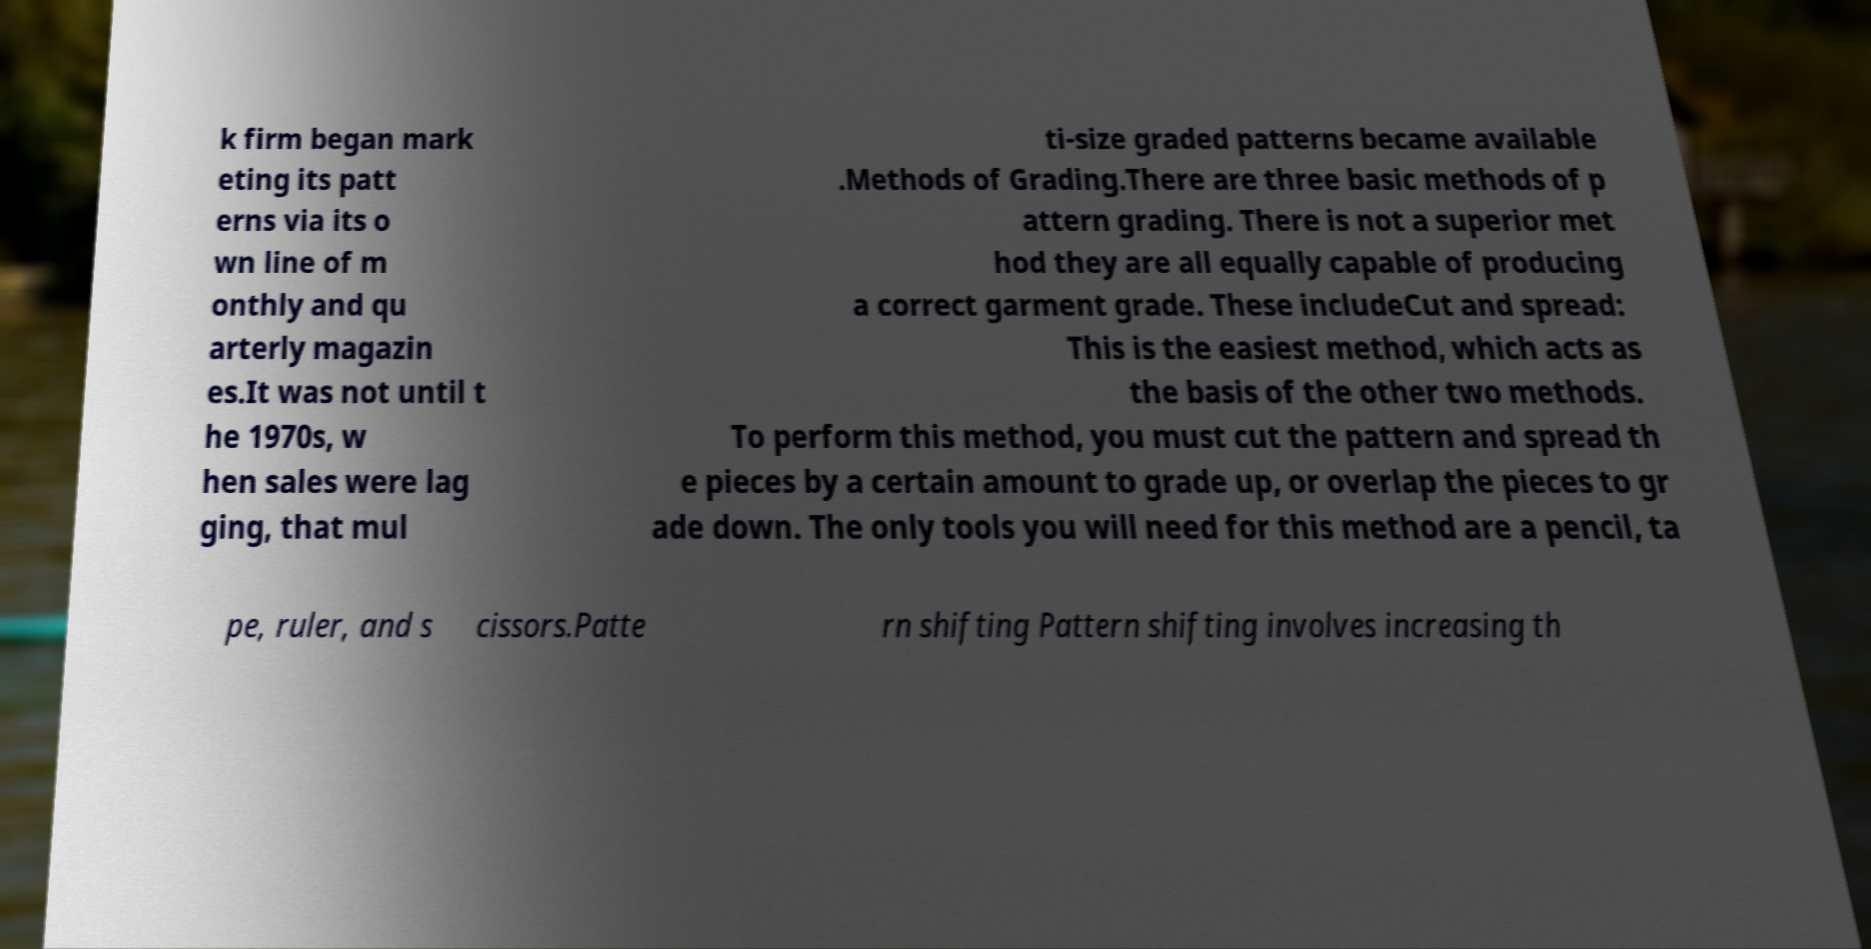Please read and relay the text visible in this image. What does it say? k firm began mark eting its patt erns via its o wn line of m onthly and qu arterly magazin es.It was not until t he 1970s, w hen sales were lag ging, that mul ti-size graded patterns became available .Methods of Grading.There are three basic methods of p attern grading. There is not a superior met hod they are all equally capable of producing a correct garment grade. These includeCut and spread: This is the easiest method, which acts as the basis of the other two methods. To perform this method, you must cut the pattern and spread th e pieces by a certain amount to grade up, or overlap the pieces to gr ade down. The only tools you will need for this method are a pencil, ta pe, ruler, and s cissors.Patte rn shifting Pattern shifting involves increasing th 